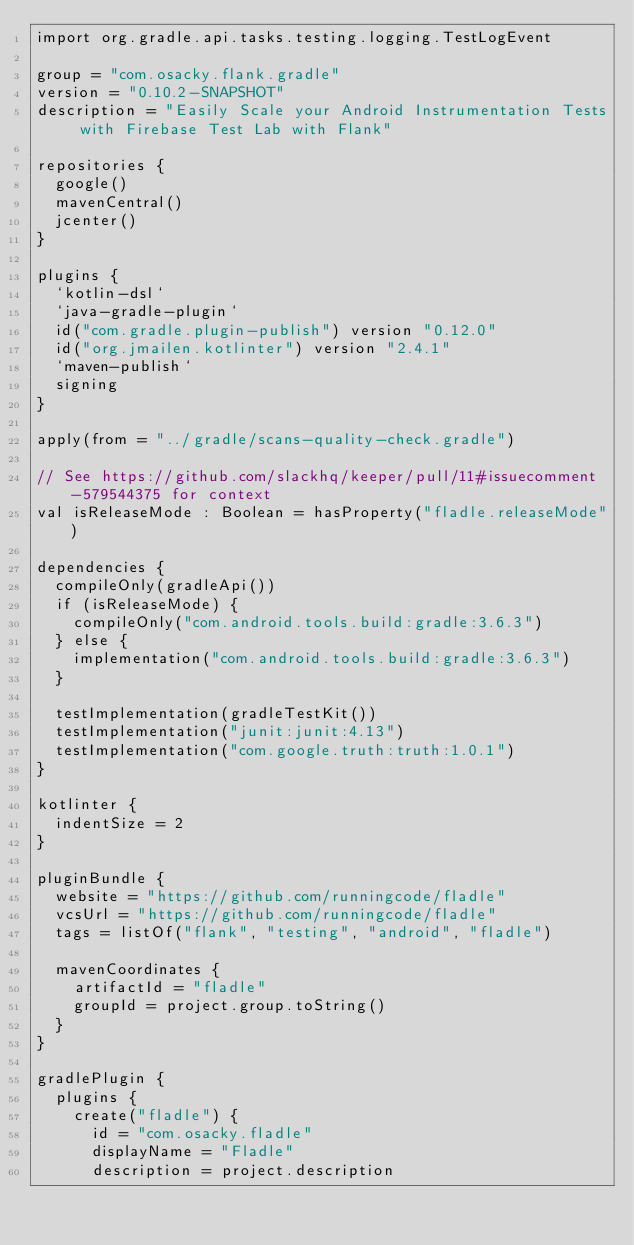<code> <loc_0><loc_0><loc_500><loc_500><_Kotlin_>import org.gradle.api.tasks.testing.logging.TestLogEvent

group = "com.osacky.flank.gradle"
version = "0.10.2-SNAPSHOT"
description = "Easily Scale your Android Instrumentation Tests with Firebase Test Lab with Flank"

repositories {
  google()
  mavenCentral()
  jcenter()
}

plugins {
  `kotlin-dsl`
  `java-gradle-plugin`
  id("com.gradle.plugin-publish") version "0.12.0"
  id("org.jmailen.kotlinter") version "2.4.1"
  `maven-publish`
  signing
}

apply(from = "../gradle/scans-quality-check.gradle")

// See https://github.com/slackhq/keeper/pull/11#issuecomment-579544375 for context
val isReleaseMode : Boolean = hasProperty("fladle.releaseMode")

dependencies {
  compileOnly(gradleApi())
  if (isReleaseMode) {
    compileOnly("com.android.tools.build:gradle:3.6.3")
  } else {
    implementation("com.android.tools.build:gradle:3.6.3")
  }

  testImplementation(gradleTestKit())
  testImplementation("junit:junit:4.13")
  testImplementation("com.google.truth:truth:1.0.1")
}

kotlinter {
  indentSize = 2
}

pluginBundle {
  website = "https://github.com/runningcode/fladle"
  vcsUrl = "https://github.com/runningcode/fladle"
  tags = listOf("flank", "testing", "android", "fladle")

  mavenCoordinates {
    artifactId = "fladle"
    groupId = project.group.toString()
  }
}

gradlePlugin {
  plugins {
    create("fladle") {
      id = "com.osacky.fladle"
      displayName = "Fladle"
      description = project.description</code> 